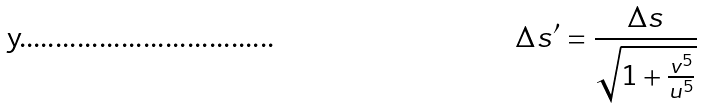Convert formula to latex. <formula><loc_0><loc_0><loc_500><loc_500>\Delta s ^ { \prime } = \frac { \Delta s } { \sqrt { 1 + \frac { v ^ { 5 } } { u ^ { 5 } } } }</formula> 